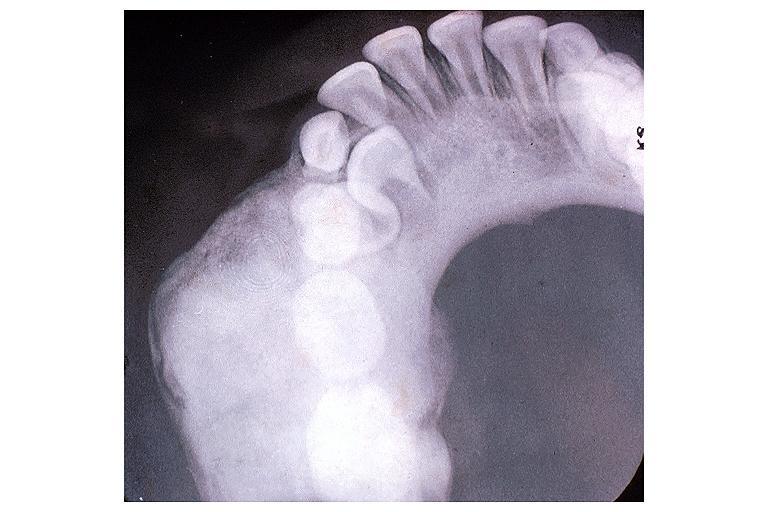what does this image show?
Answer the question using a single word or phrase. Osteoblastoma 